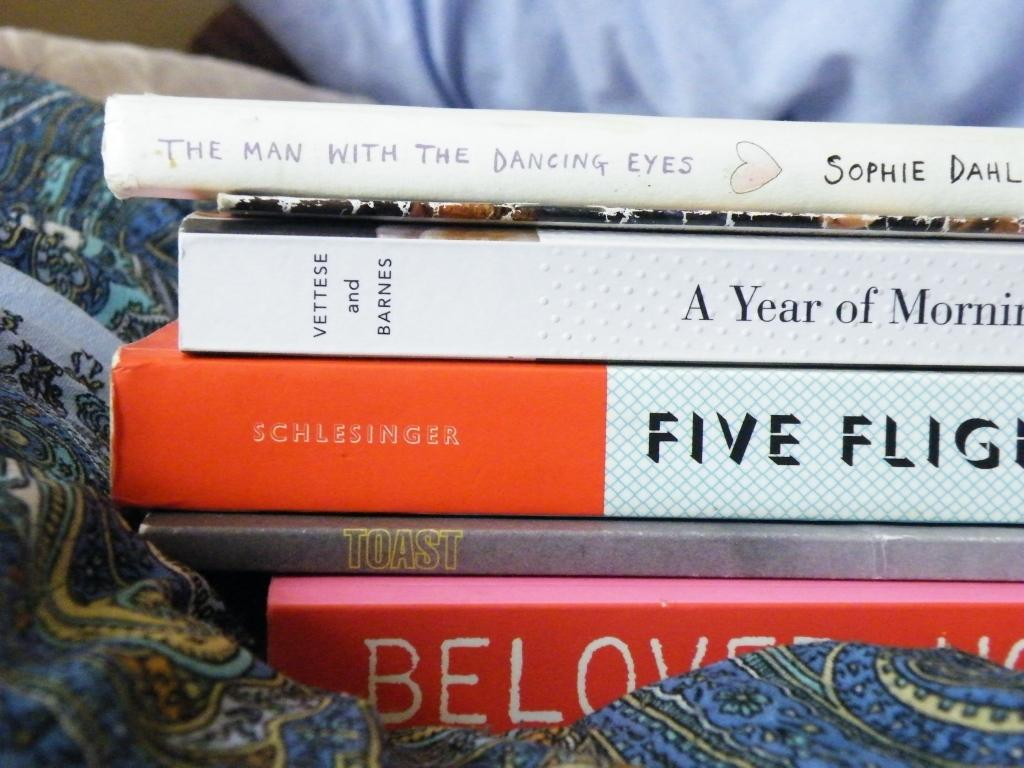<image>
Offer a succinct explanation of the picture presented. blue patterned fabric underneath bookins including toast, a year of morning, and the man with the dancing eyes, and others 